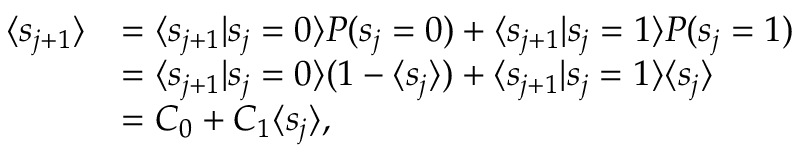Convert formula to latex. <formula><loc_0><loc_0><loc_500><loc_500>\begin{array} { r l } { \langle s _ { j + 1 } \rangle } & { = \langle s _ { j + 1 } | s _ { j } = 0 \rangle P ( s _ { j } = 0 ) + \langle s _ { j + 1 } | s _ { j } = 1 \rangle P ( s _ { j } = 1 ) } \\ & { = \langle s _ { j + 1 } | s _ { j } = 0 \rangle ( 1 - \langle s _ { j } \rangle ) + \langle s _ { j + 1 } | s _ { j } = 1 \rangle \langle s _ { j } \rangle } \\ & { = C _ { 0 } + C _ { 1 } \langle s _ { j } \rangle , } \end{array}</formula> 